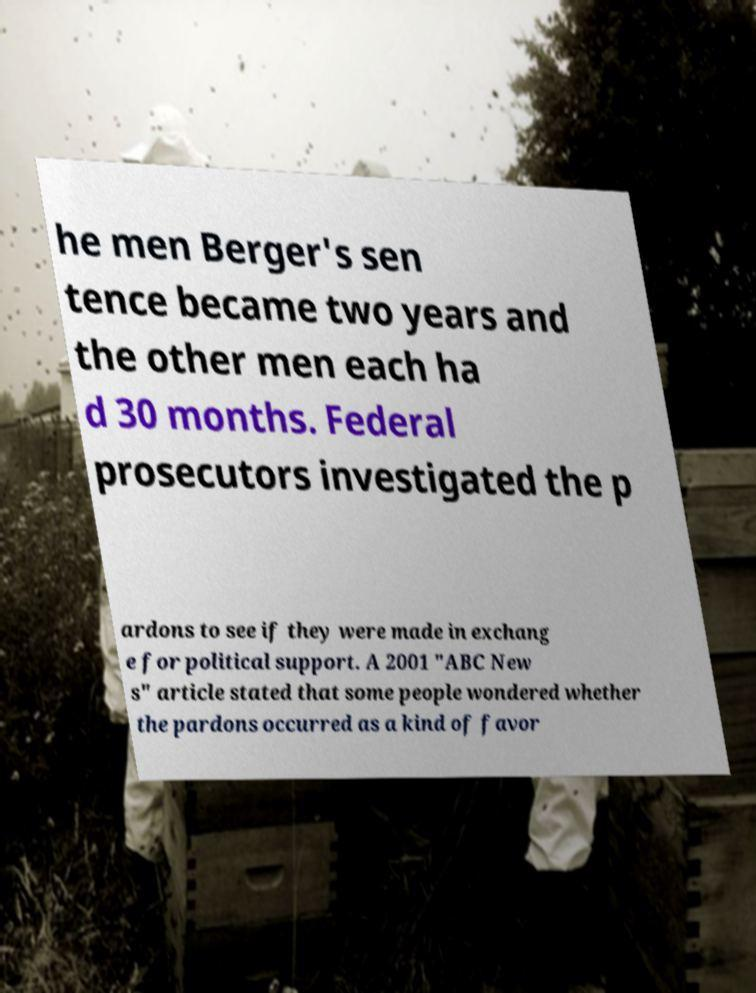Can you accurately transcribe the text from the provided image for me? he men Berger's sen tence became two years and the other men each ha d 30 months. Federal prosecutors investigated the p ardons to see if they were made in exchang e for political support. A 2001 "ABC New s" article stated that some people wondered whether the pardons occurred as a kind of favor 